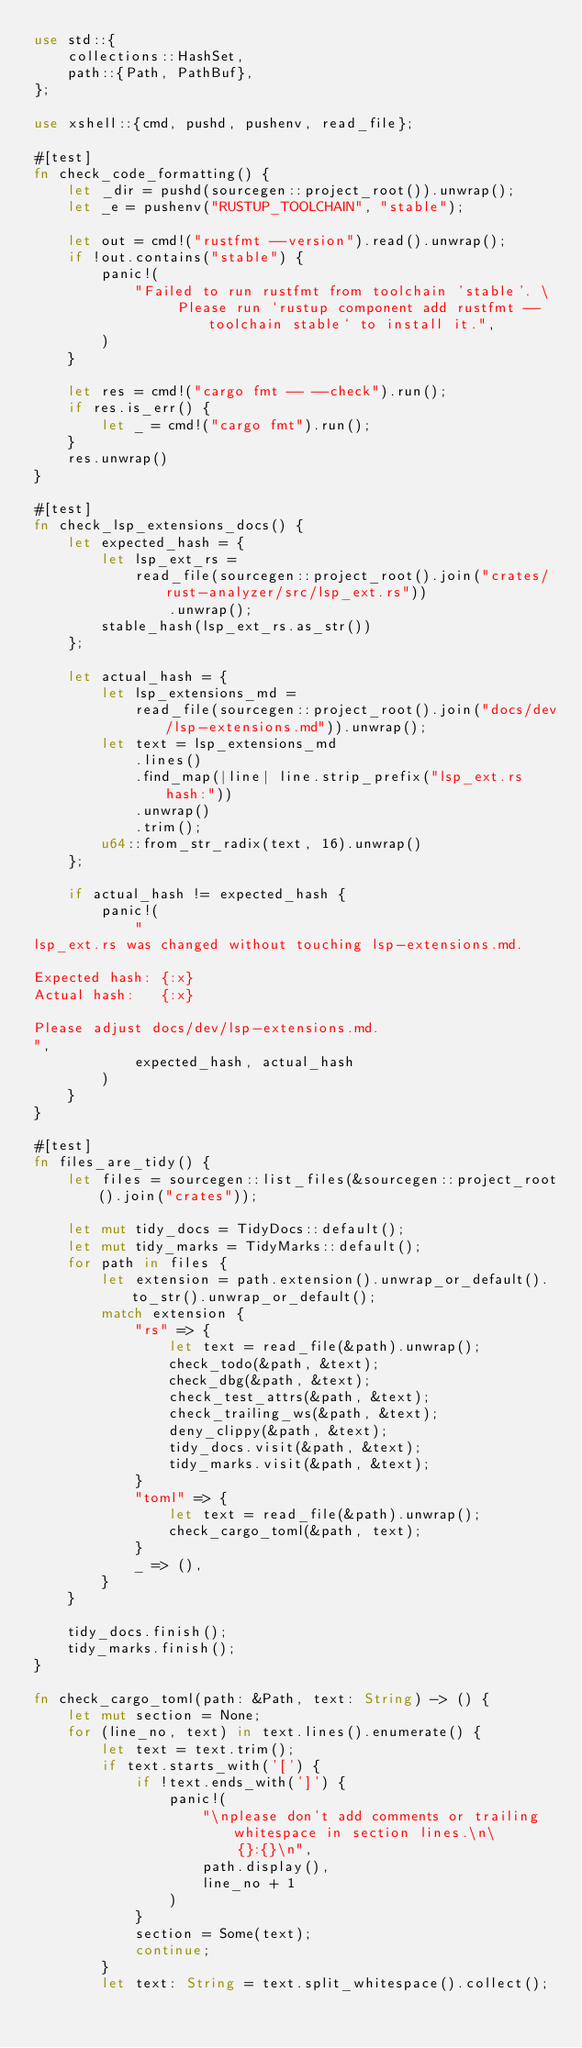Convert code to text. <code><loc_0><loc_0><loc_500><loc_500><_Rust_>use std::{
    collections::HashSet,
    path::{Path, PathBuf},
};

use xshell::{cmd, pushd, pushenv, read_file};

#[test]
fn check_code_formatting() {
    let _dir = pushd(sourcegen::project_root()).unwrap();
    let _e = pushenv("RUSTUP_TOOLCHAIN", "stable");

    let out = cmd!("rustfmt --version").read().unwrap();
    if !out.contains("stable") {
        panic!(
            "Failed to run rustfmt from toolchain 'stable'. \
                 Please run `rustup component add rustfmt --toolchain stable` to install it.",
        )
    }

    let res = cmd!("cargo fmt -- --check").run();
    if res.is_err() {
        let _ = cmd!("cargo fmt").run();
    }
    res.unwrap()
}

#[test]
fn check_lsp_extensions_docs() {
    let expected_hash = {
        let lsp_ext_rs =
            read_file(sourcegen::project_root().join("crates/rust-analyzer/src/lsp_ext.rs"))
                .unwrap();
        stable_hash(lsp_ext_rs.as_str())
    };

    let actual_hash = {
        let lsp_extensions_md =
            read_file(sourcegen::project_root().join("docs/dev/lsp-extensions.md")).unwrap();
        let text = lsp_extensions_md
            .lines()
            .find_map(|line| line.strip_prefix("lsp_ext.rs hash:"))
            .unwrap()
            .trim();
        u64::from_str_radix(text, 16).unwrap()
    };

    if actual_hash != expected_hash {
        panic!(
            "
lsp_ext.rs was changed without touching lsp-extensions.md.

Expected hash: {:x}
Actual hash:   {:x}

Please adjust docs/dev/lsp-extensions.md.
",
            expected_hash, actual_hash
        )
    }
}

#[test]
fn files_are_tidy() {
    let files = sourcegen::list_files(&sourcegen::project_root().join("crates"));

    let mut tidy_docs = TidyDocs::default();
    let mut tidy_marks = TidyMarks::default();
    for path in files {
        let extension = path.extension().unwrap_or_default().to_str().unwrap_or_default();
        match extension {
            "rs" => {
                let text = read_file(&path).unwrap();
                check_todo(&path, &text);
                check_dbg(&path, &text);
                check_test_attrs(&path, &text);
                check_trailing_ws(&path, &text);
                deny_clippy(&path, &text);
                tidy_docs.visit(&path, &text);
                tidy_marks.visit(&path, &text);
            }
            "toml" => {
                let text = read_file(&path).unwrap();
                check_cargo_toml(&path, text);
            }
            _ => (),
        }
    }

    tidy_docs.finish();
    tidy_marks.finish();
}

fn check_cargo_toml(path: &Path, text: String) -> () {
    let mut section = None;
    for (line_no, text) in text.lines().enumerate() {
        let text = text.trim();
        if text.starts_with('[') {
            if !text.ends_with(']') {
                panic!(
                    "\nplease don't add comments or trailing whitespace in section lines.\n\
                        {}:{}\n",
                    path.display(),
                    line_no + 1
                )
            }
            section = Some(text);
            continue;
        }
        let text: String = text.split_whitespace().collect();</code> 